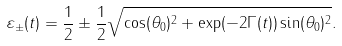Convert formula to latex. <formula><loc_0><loc_0><loc_500><loc_500>\varepsilon _ { \pm } ( t ) = \frac { 1 } { 2 } \pm \frac { 1 } { 2 } \sqrt { \cos ( \theta _ { 0 } ) ^ { 2 } + \exp ( - 2 \Gamma ( t ) ) \sin ( \theta _ { 0 } ) ^ { 2 } } .</formula> 